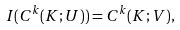Convert formula to latex. <formula><loc_0><loc_0><loc_500><loc_500>I ( C ^ { k } ( K ; U ) ) = C ^ { k } ( K ; V ) ,</formula> 